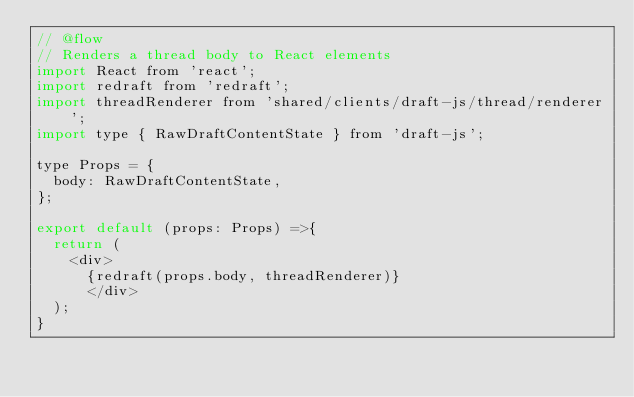<code> <loc_0><loc_0><loc_500><loc_500><_JavaScript_>// @flow
// Renders a thread body to React elements
import React from 'react';
import redraft from 'redraft';
import threadRenderer from 'shared/clients/draft-js/thread/renderer';
import type { RawDraftContentState } from 'draft-js';

type Props = {
  body: RawDraftContentState,
};

export default (props: Props) =>{
  return (
    <div>
      {redraft(props.body, threadRenderer)}
      </div>
  );
} 
</code> 